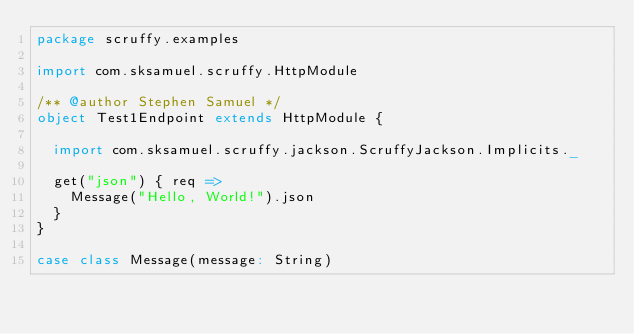Convert code to text. <code><loc_0><loc_0><loc_500><loc_500><_Scala_>package scruffy.examples

import com.sksamuel.scruffy.HttpModule

/** @author Stephen Samuel */
object Test1Endpoint extends HttpModule {

  import com.sksamuel.scruffy.jackson.ScruffyJackson.Implicits._

  get("json") { req =>
    Message("Hello, World!").json
  }
}

case class Message(message: String)</code> 